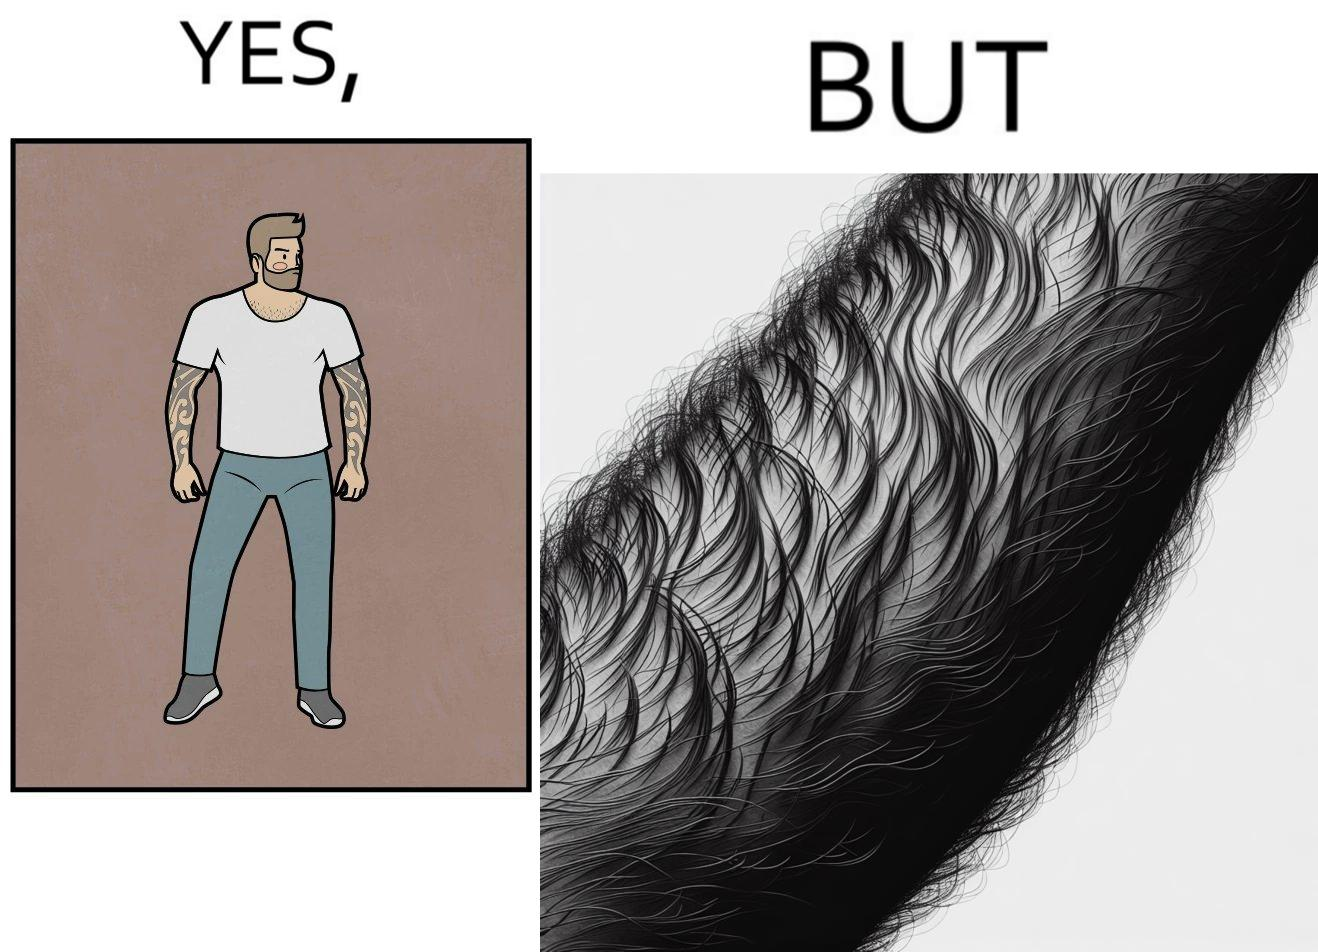What is the satirical meaning behind this image? The image is funny because while from the distance it seems that the man has big tattoos on both of his arms upon a closer look at the arms it turns out there is no tattoo and what seemed to be tattoos are just hairs on his arm. 